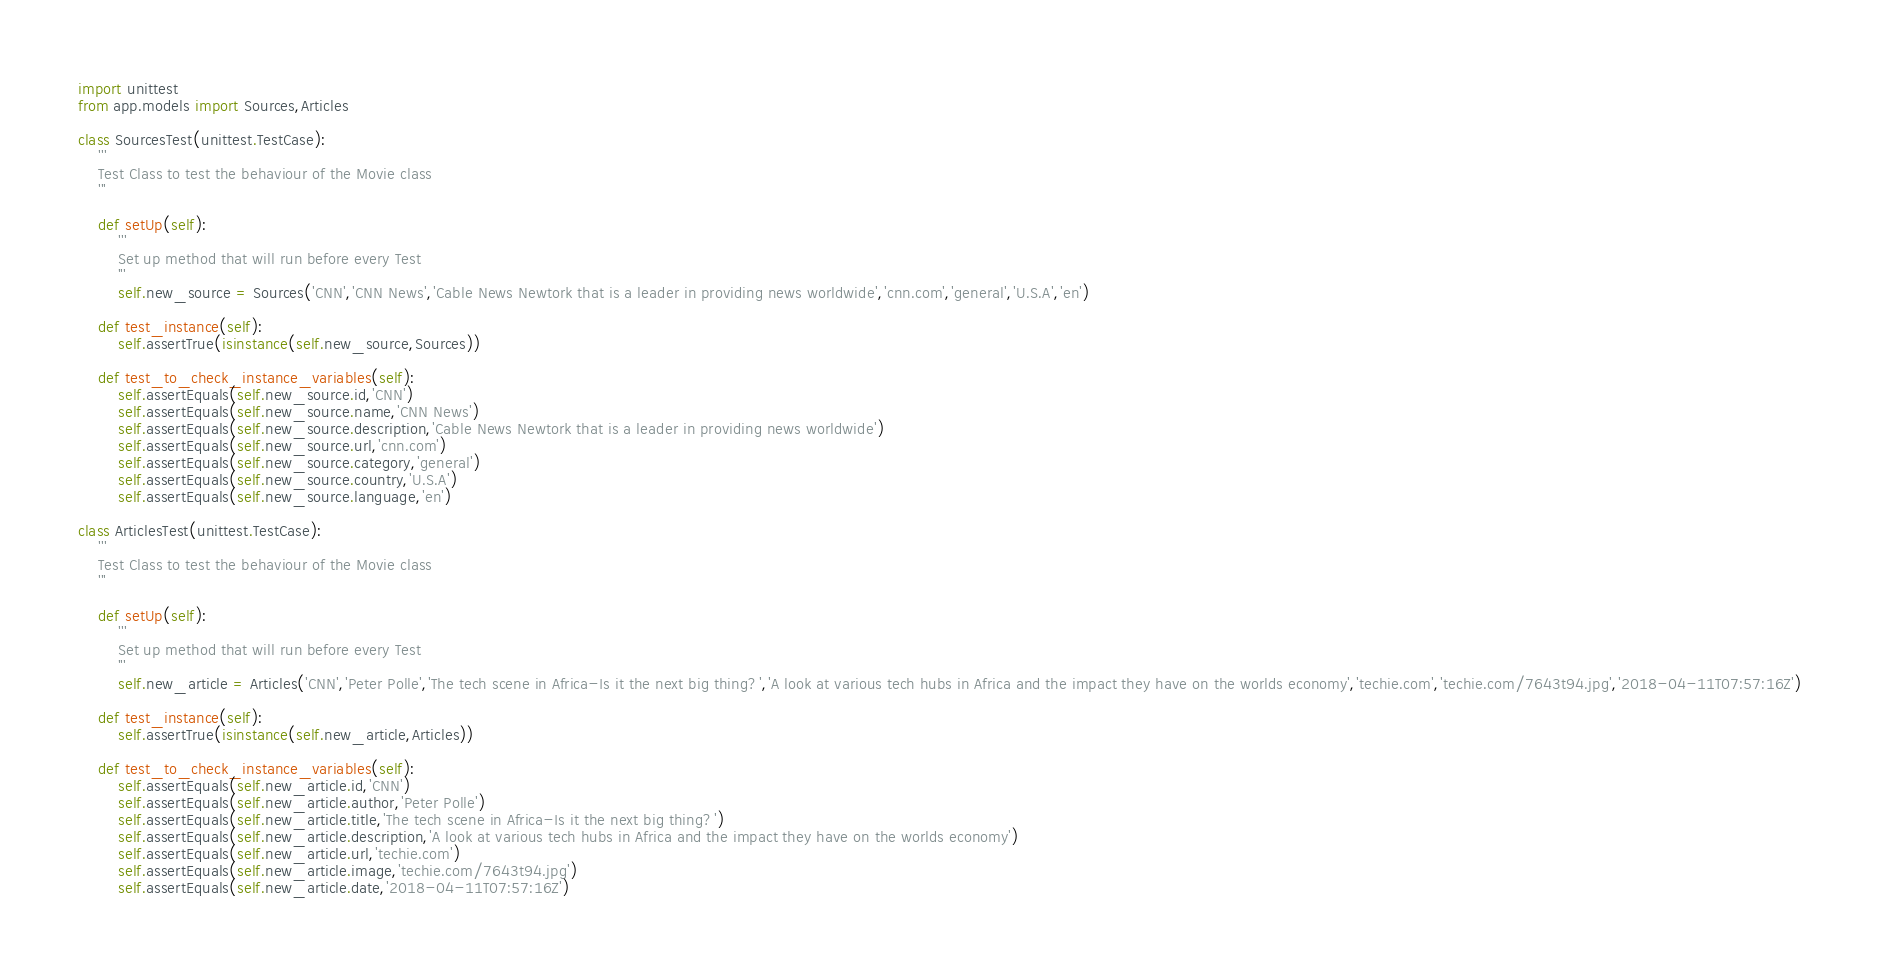<code> <loc_0><loc_0><loc_500><loc_500><_Python_>
import unittest
from app.models import Sources,Articles

class SourcesTest(unittest.TestCase):
    '''
    Test Class to test the behaviour of the Movie class
    '''

    def setUp(self):
        '''
        Set up method that will run before every Test
        '''
        self.new_source = Sources('CNN','CNN News','Cable News Newtork that is a leader in providing news worldwide','cnn.com','general','U.S.A','en')

    def test_instance(self):
        self.assertTrue(isinstance(self.new_source,Sources))

    def test_to_check_instance_variables(self):
        self.assertEquals(self.new_source.id,'CNN')
        self.assertEquals(self.new_source.name,'CNN News')
        self.assertEquals(self.new_source.description,'Cable News Newtork that is a leader in providing news worldwide')
        self.assertEquals(self.new_source.url,'cnn.com')
        self.assertEquals(self.new_source.category,'general')
        self.assertEquals(self.new_source.country,'U.S.A')
        self.assertEquals(self.new_source.language,'en')

class ArticlesTest(unittest.TestCase):
    '''
    Test Class to test the behaviour of the Movie class
    '''

    def setUp(self):
        '''
        Set up method that will run before every Test
        '''
        self.new_article = Articles('CNN','Peter Polle','The tech scene in Africa-Is it the next big thing?','A look at various tech hubs in Africa and the impact they have on the worlds economy','techie.com','techie.com/7643t94.jpg','2018-04-11T07:57:16Z')

    def test_instance(self):
        self.assertTrue(isinstance(self.new_article,Articles))

    def test_to_check_instance_variables(self):
        self.assertEquals(self.new_article.id,'CNN')
        self.assertEquals(self.new_article.author,'Peter Polle')
        self.assertEquals(self.new_article.title,'The tech scene in Africa-Is it the next big thing?')
        self.assertEquals(self.new_article.description,'A look at various tech hubs in Africa and the impact they have on the worlds economy')
        self.assertEquals(self.new_article.url,'techie.com')
        self.assertEquals(self.new_article.image,'techie.com/7643t94.jpg')
        self.assertEquals(self.new_article.date,'2018-04-11T07:57:16Z')</code> 